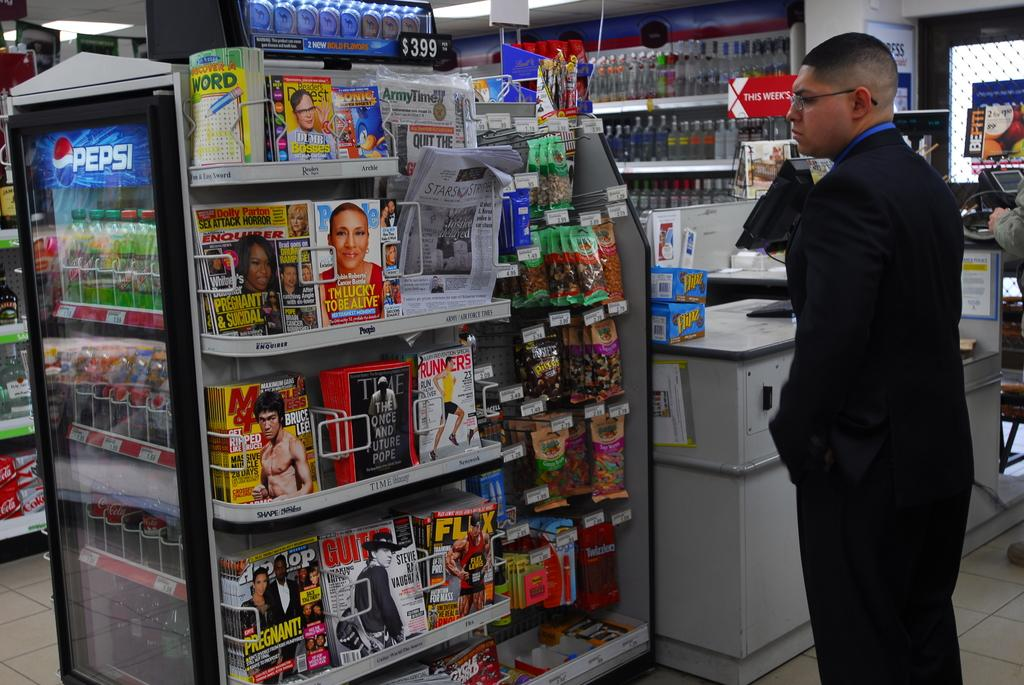<image>
Present a compact description of the photo's key features. A man looking at a magazine rack with People and Time prominently displayed. 